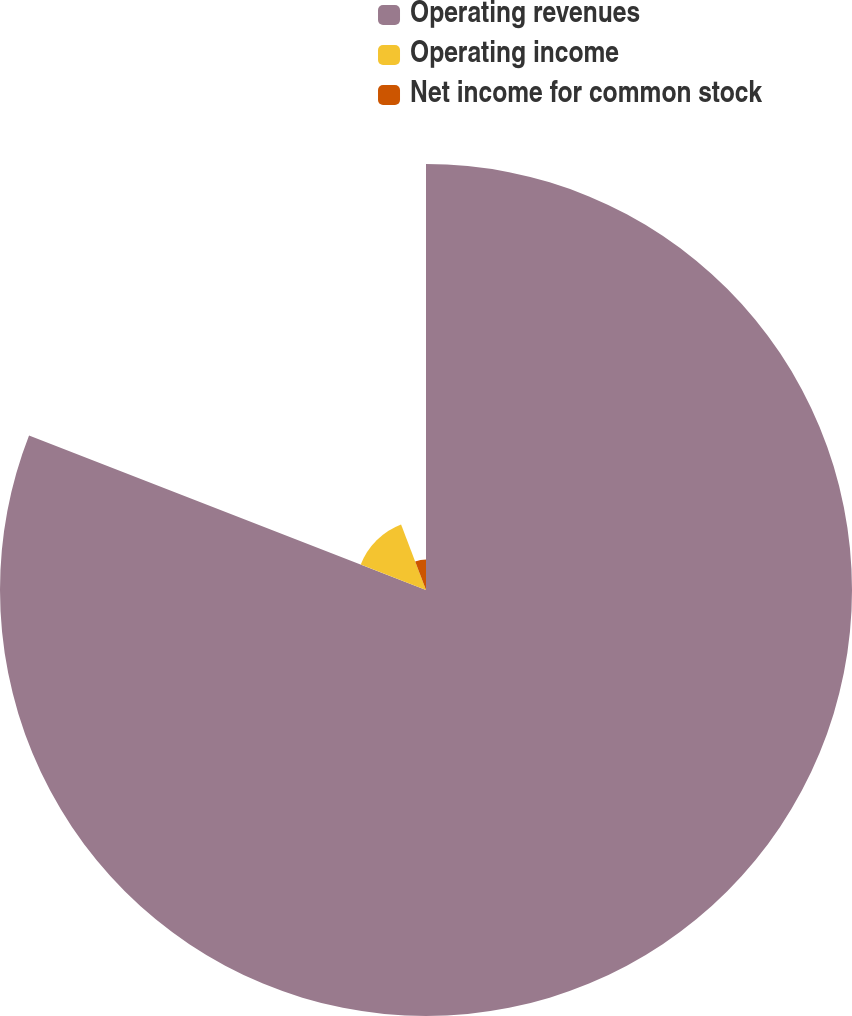Convert chart. <chart><loc_0><loc_0><loc_500><loc_500><pie_chart><fcel>Operating revenues<fcel>Operating income<fcel>Net income for common stock<nl><fcel>80.91%<fcel>13.3%<fcel>5.79%<nl></chart> 